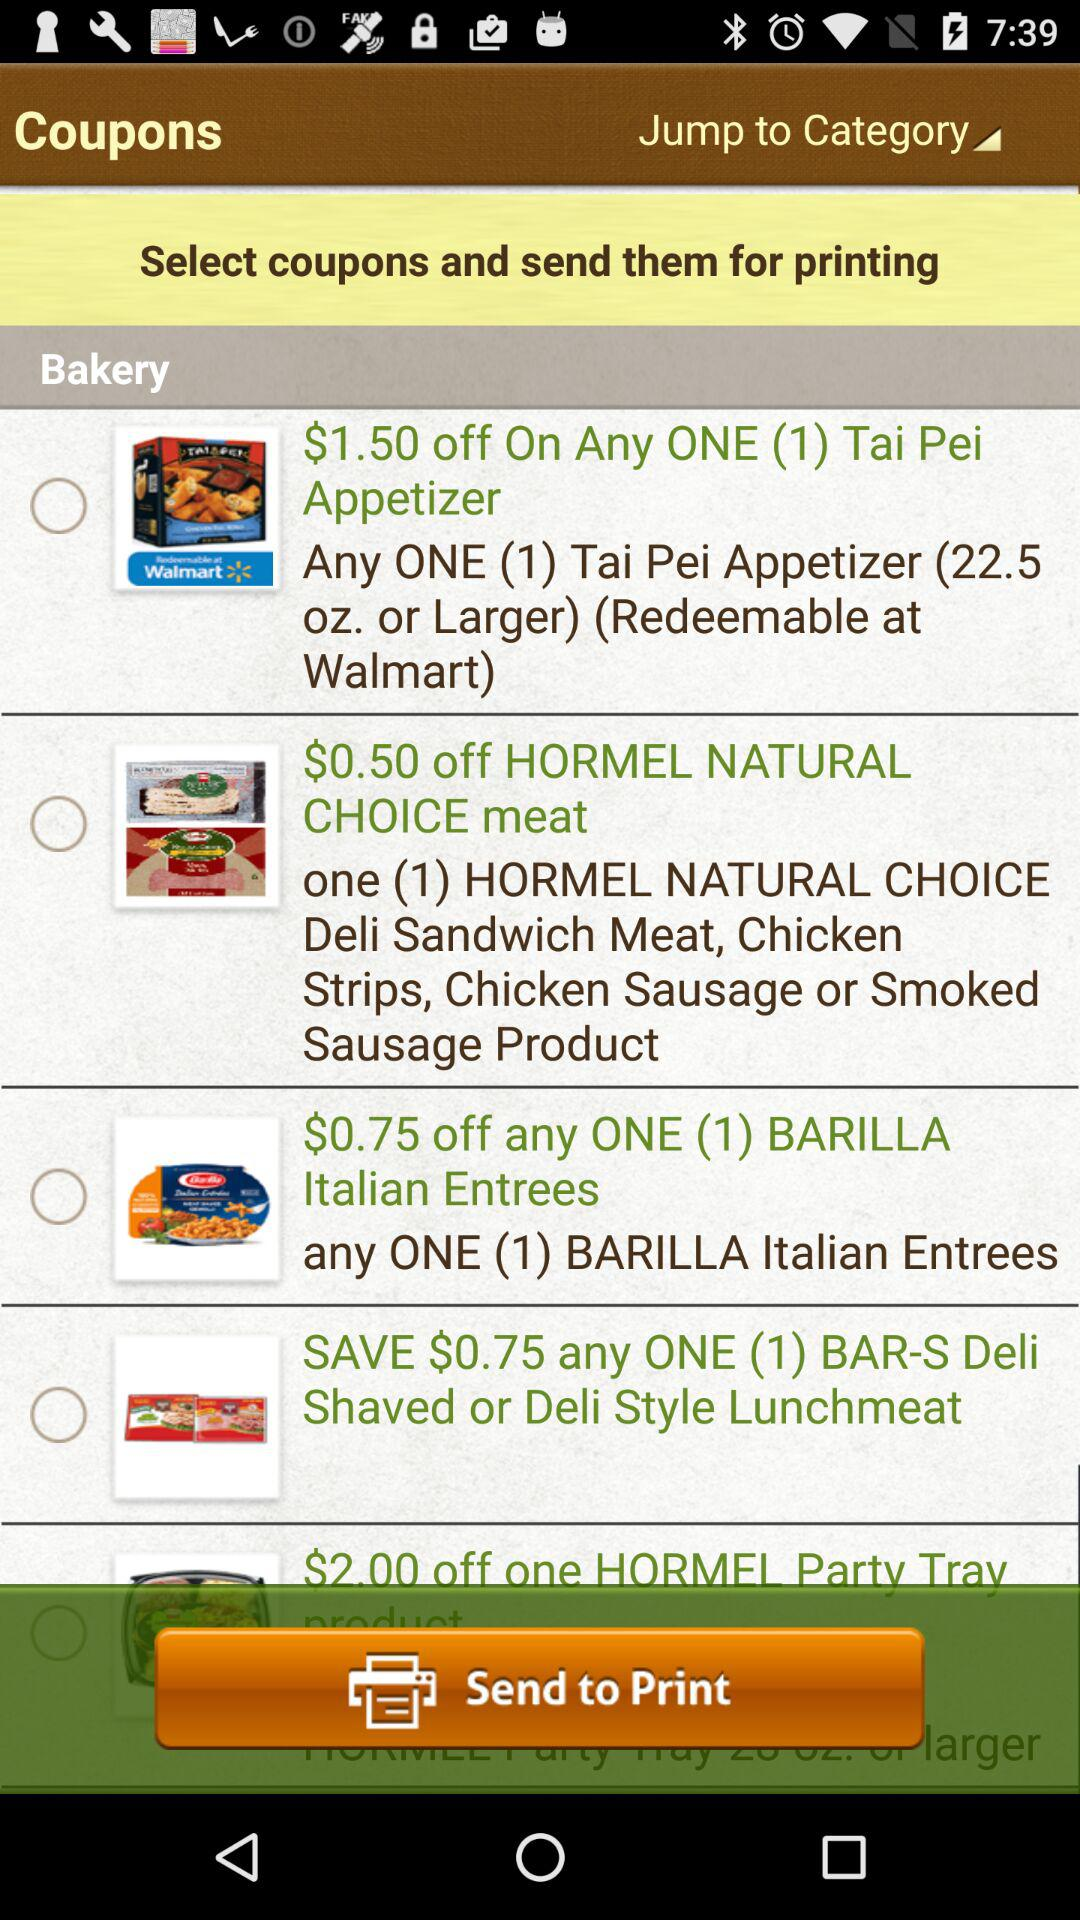How much of a discount is available on "Tai Pei Appetizer"? There is a $1.50 discount on "Tai Pei Appetizer". 